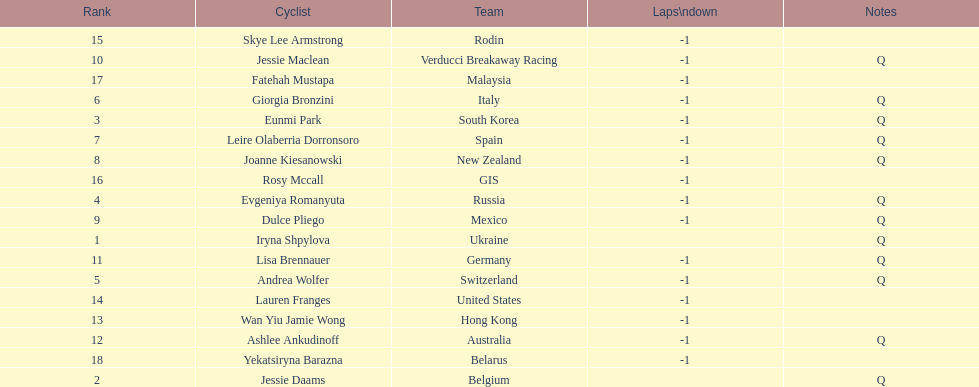What is the number rank of belgium? 2. 